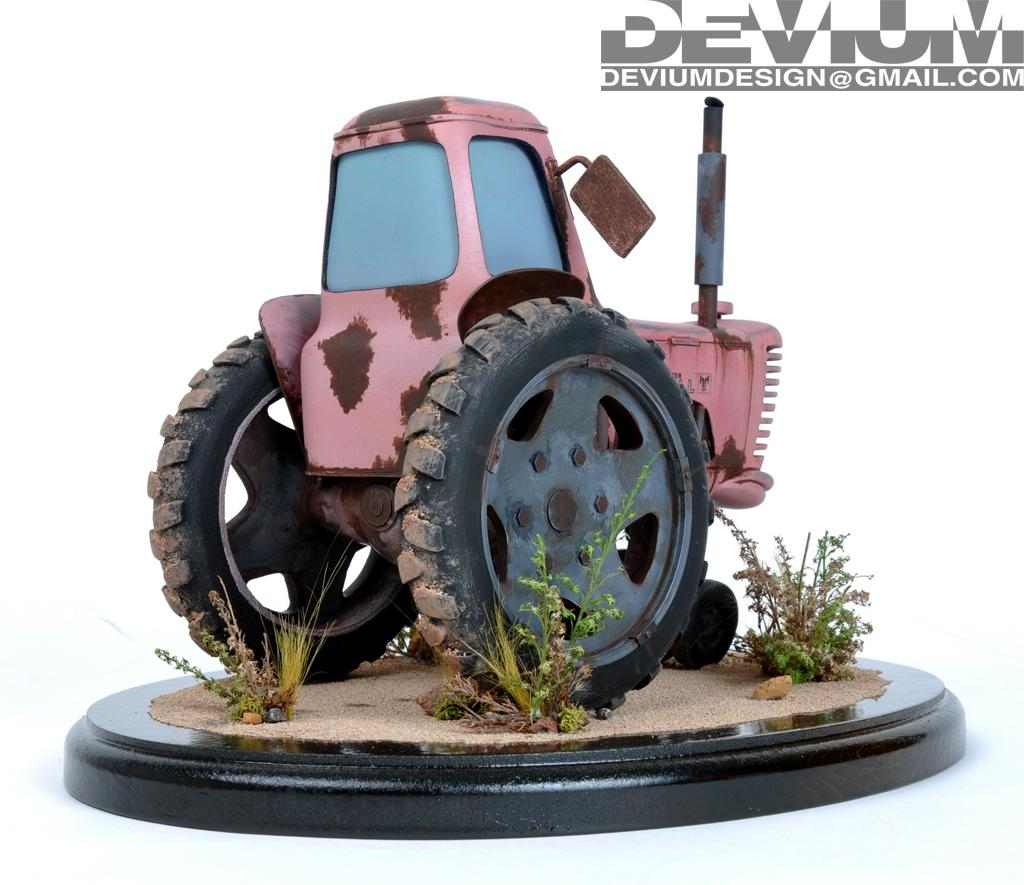What type of toy is present in the image? The image contains a toy tractor. What else can be seen in the image besides the toy tractor? There are plants in the image. Is there any text present in the image? Yes, there is text in the top right corner of the image. What type of suit is the crow wearing in the image? There is no crow or suit present in the image. How many cups can be seen in the image? There are no cups present in the image. 